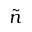Convert formula to latex. <formula><loc_0><loc_0><loc_500><loc_500>\tilde { n }</formula> 